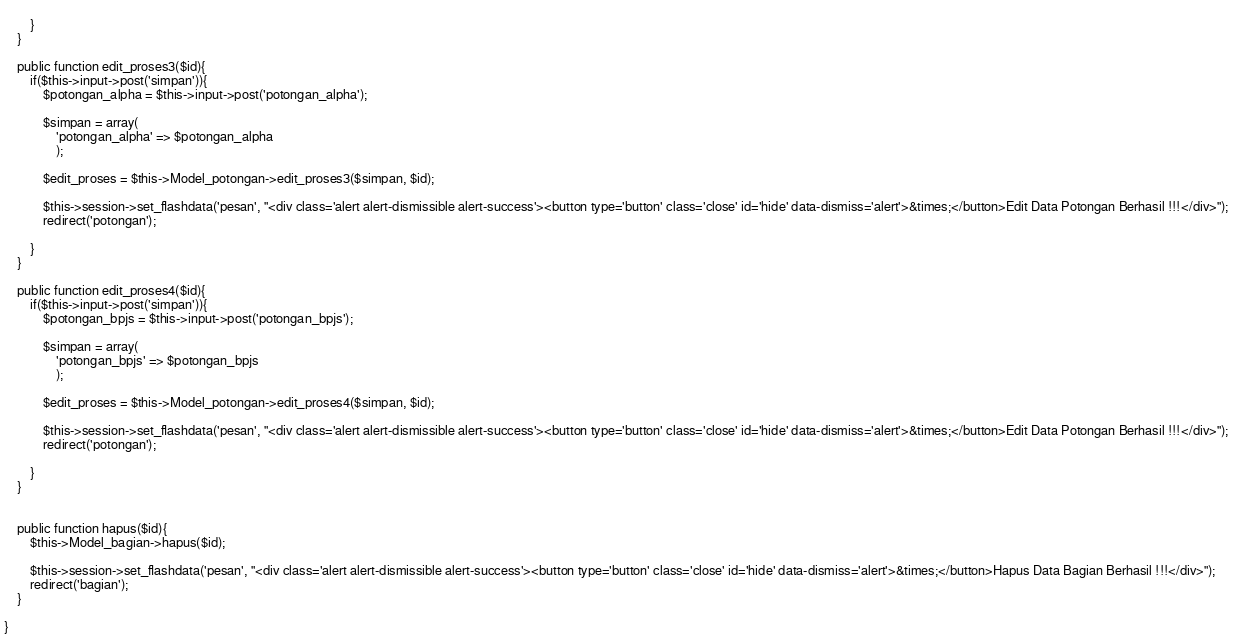<code> <loc_0><loc_0><loc_500><loc_500><_PHP_>			
		}
	}

	public function edit_proses3($id){
		if($this->input->post('simpan')){
			$potongan_alpha = $this->input->post('potongan_alpha');

			$simpan = array(
				'potongan_alpha' => $potongan_alpha
				);

			$edit_proses = $this->Model_potongan->edit_proses3($simpan, $id);

			$this->session->set_flashdata('pesan', "<div class='alert alert-dismissible alert-success'><button type='button' class='close' id='hide' data-dismiss='alert'>&times;</button>Edit Data Potongan Berhasil !!!</div>");
			redirect('potongan');
			
		}
	}

	public function edit_proses4($id){
		if($this->input->post('simpan')){
			$potongan_bpjs = $this->input->post('potongan_bpjs');

			$simpan = array(
				'potongan_bpjs' => $potongan_bpjs
				);

			$edit_proses = $this->Model_potongan->edit_proses4($simpan, $id);

			$this->session->set_flashdata('pesan', "<div class='alert alert-dismissible alert-success'><button type='button' class='close' id='hide' data-dismiss='alert'>&times;</button>Edit Data Potongan Berhasil !!!</div>");
			redirect('potongan');
			
		}
	}


	public function hapus($id){
		$this->Model_bagian->hapus($id);

		$this->session->set_flashdata('pesan', "<div class='alert alert-dismissible alert-success'><button type='button' class='close' id='hide' data-dismiss='alert'>&times;</button>Hapus Data Bagian Berhasil !!!</div>");
		redirect('bagian');
	}

}
</code> 